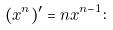Convert formula to latex. <formula><loc_0><loc_0><loc_500><loc_500>( x ^ { n } ) ^ { \prime } = n x ^ { n - 1 } \colon</formula> 